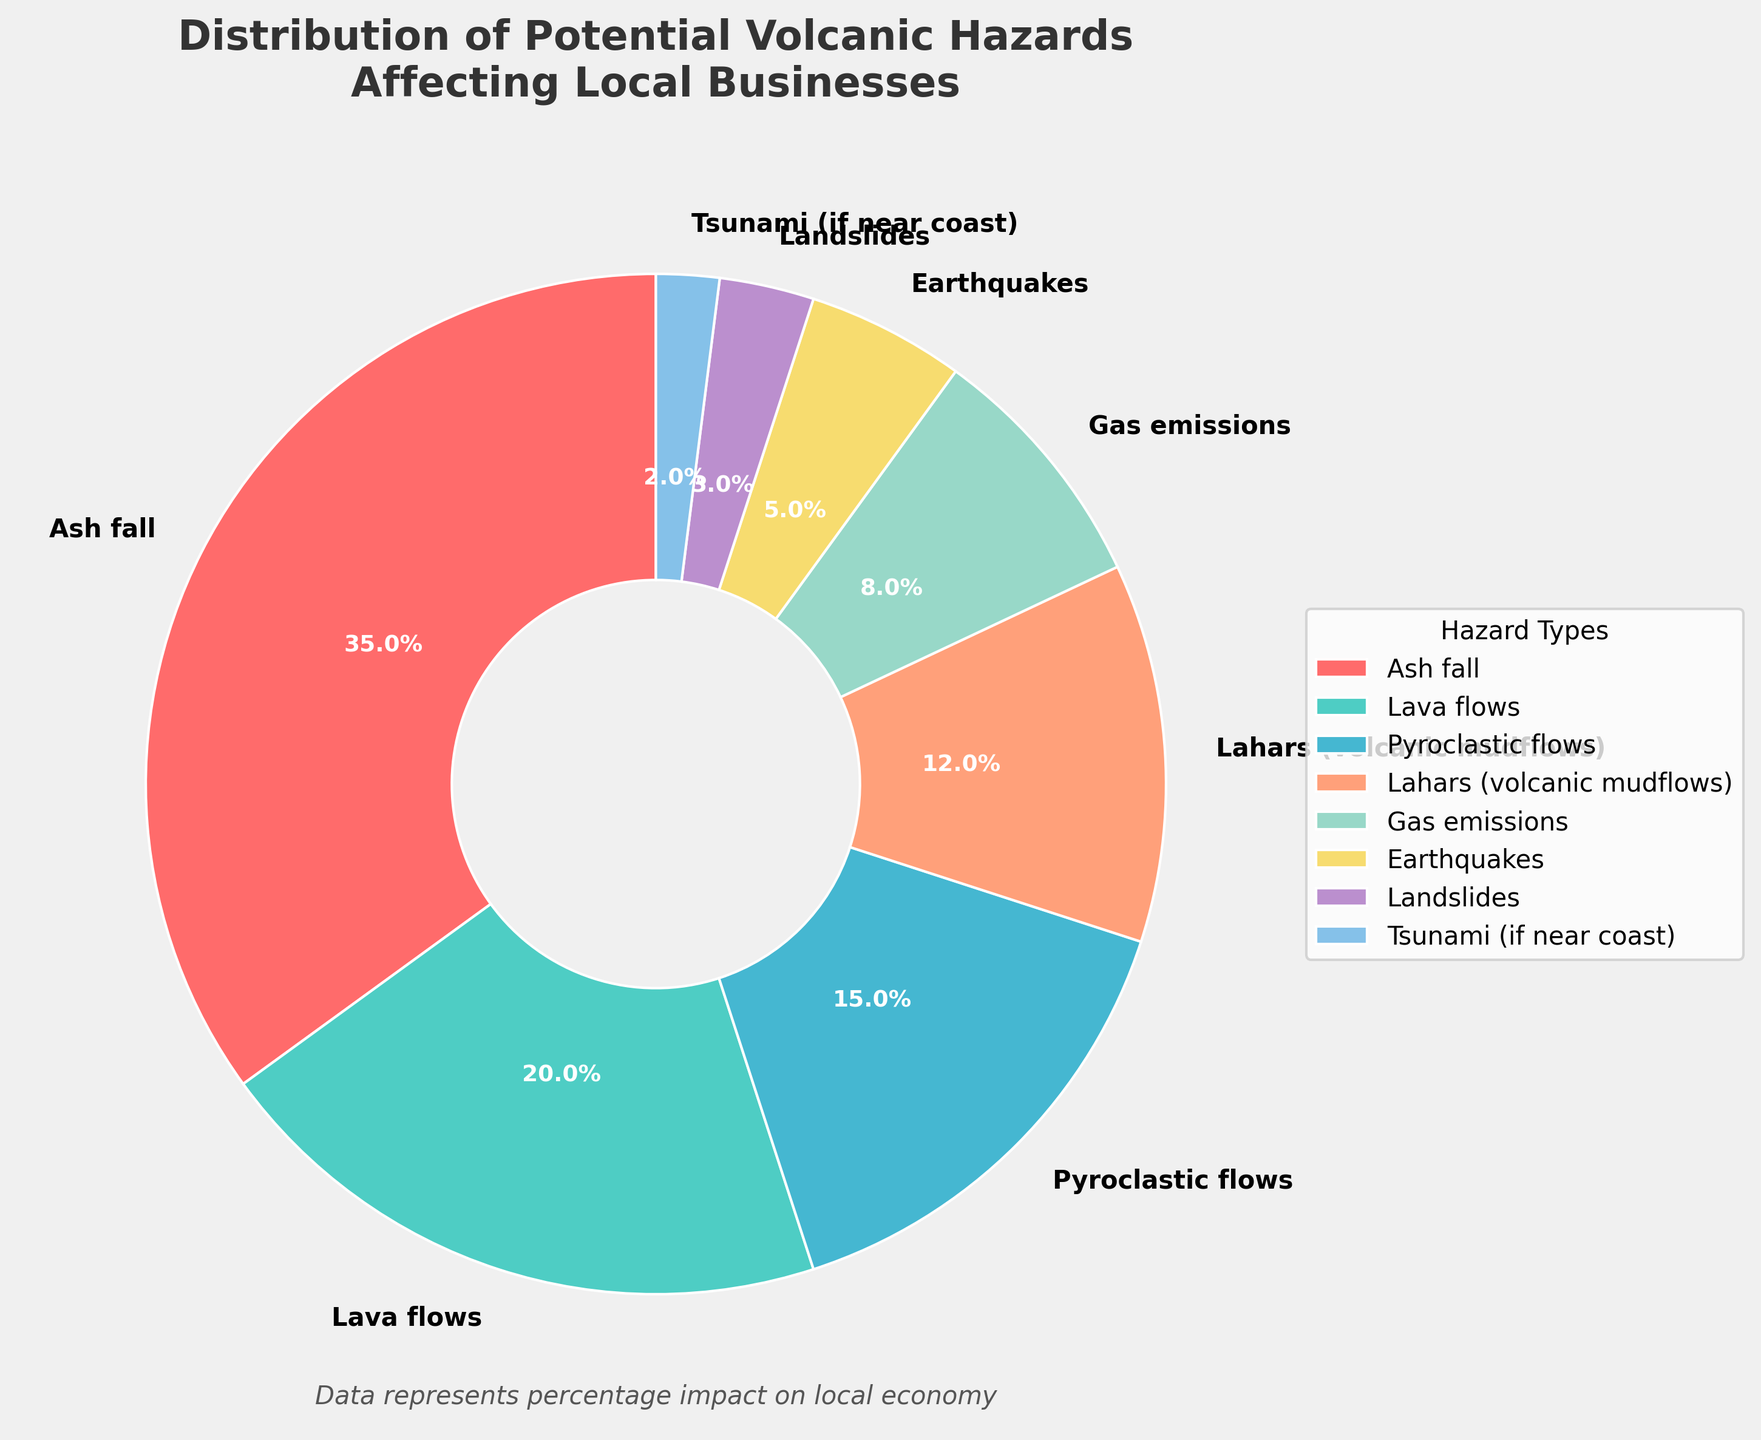What is the most common volcanic hazard affecting local businesses? The pie chart shows various hazards with their corresponding percentages. The largest section represents Ash fall with 35%, making it the most common hazard.
Answer: Ash fall Which hazards combined affect less than 10% of the local businesses? By looking at the chart, the two smallest sections are Landslides (3%) and Tsunami (if near coast) (2%), summing them gives 3% + 2% = 5%.
Answer: Landslides and Tsunami How much more impact does Ash fall have compared to Gas emissions? The percentage of Ash fall is 35%, and the percentage of Gas emissions is 8%. By subtracting these two values, we get 35% - 8% = 27%.
Answer: 27% Compare the impact of Lahars and Pyroclastic flows? Lahars have a percentage of 12% whereas Pyroclastic flows have 15%. Pyroclastic flows impact 3% more businesses compared to Lahars.
Answer: Pyroclastic flows have 3% more impact How do Lava flows and Pyroclastic flows together impact local businesses compared to Ash fall alone? Lava flows (20%) and Pyroclastic flows (15%) together sum up to 20% + 15% = 35%, which is the same as Ash fall alone at 35%.
Answer: They have the same impact What percentage of local businesses are affected by hazards other than Ash fall, Lava flows, and Pyroclastic flows? Sum up the percentages of Lahars (12%), Gas emissions (8%), Earthquakes (5%), Landslides (3%), and Tsunami (2%). This results in 12% + 8% + 5% + 3% + 2% = 30%.
Answer: 30% Which hazard category is depicted in a light blue color in the pie chart? By observing the colors in the chart, light blue corresponds to Lava flows, which has an impact of 20%.
Answer: Lava flows What is the total impact percentage of hazards related to molten rock (Lava flows and Pyroclastic flows)? The percentages for Lava flows and Pyroclastic flows are 20% and 15% respectively. Summing them gives 20% + 15% = 35%.
Answer: 35% If the impact of Gas emissions doubled, what would be its new percentage and how would it compare to Ash fall? The current percentage of Gas emissions is 8%. Doubling it gives 8% * 2 = 16%. This would be 19% less than Ash fall (35% - 16% = 19%).
Answer: It would be 16%, which is 19% less than Ash fall 